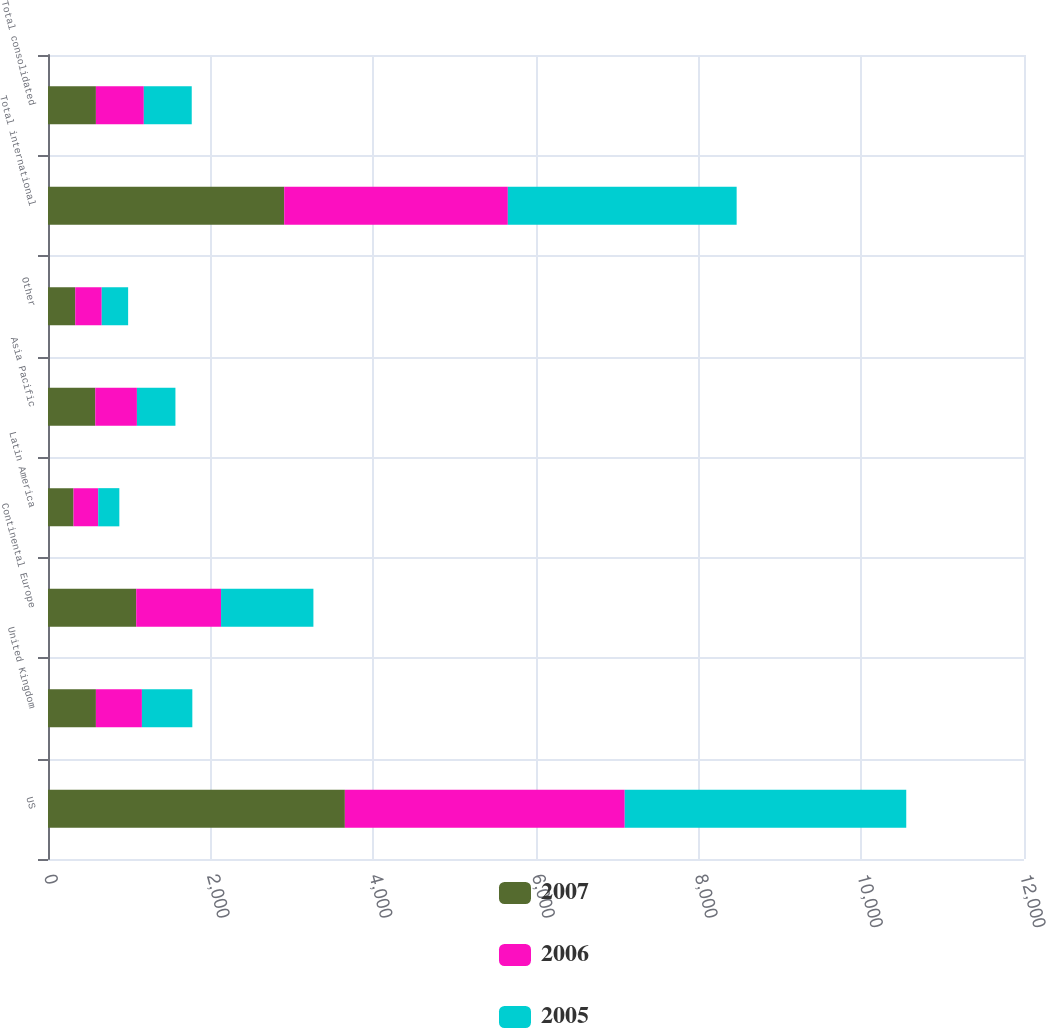Convert chart to OTSL. <chart><loc_0><loc_0><loc_500><loc_500><stacked_bar_chart><ecel><fcel>US<fcel>United Kingdom<fcel>Continental Europe<fcel>Latin America<fcel>Asia Pacific<fcel>Other<fcel>Total international<fcel>Total consolidated<nl><fcel>2007<fcel>3650<fcel>589.1<fcel>1084.7<fcel>314.1<fcel>581.3<fcel>335<fcel>2904.2<fcel>589.1<nl><fcel>2006<fcel>3441.2<fcel>565.6<fcel>1043<fcel>303.4<fcel>512<fcel>325.6<fcel>2749.6<fcel>589.1<nl><fcel>2005<fcel>3461.1<fcel>619.9<fcel>1135.5<fcel>259.7<fcel>473.5<fcel>324.6<fcel>2813.2<fcel>589.1<nl></chart> 